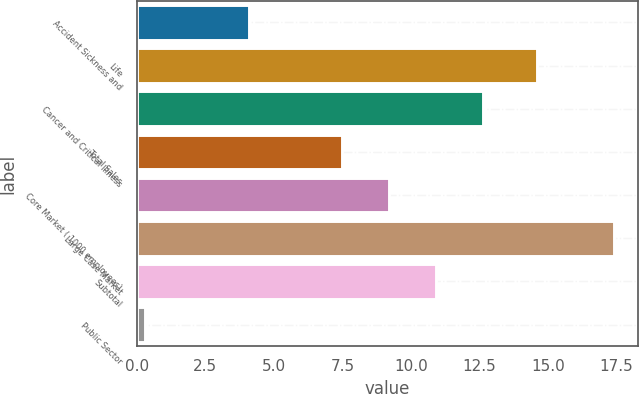Convert chart. <chart><loc_0><loc_0><loc_500><loc_500><bar_chart><fcel>Accident Sickness and<fcel>Life<fcel>Cancer and Critical Illness<fcel>Total Sales<fcel>Core Market ( 1000 employees)<fcel>Large Case Market<fcel>Subtotal<fcel>Public Sector<nl><fcel>4.1<fcel>14.6<fcel>12.63<fcel>7.5<fcel>9.21<fcel>17.4<fcel>10.92<fcel>0.3<nl></chart> 